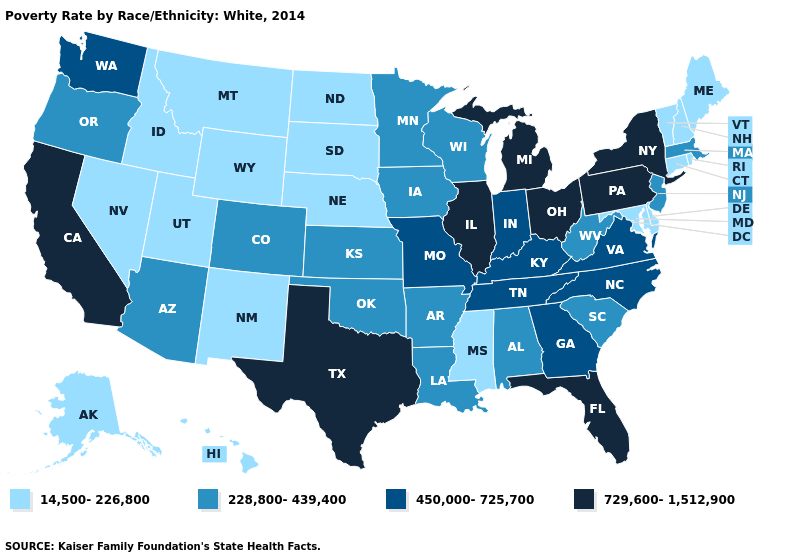What is the highest value in the Northeast ?
Short answer required. 729,600-1,512,900. What is the value of New York?
Concise answer only. 729,600-1,512,900. Among the states that border Nebraska , which have the highest value?
Keep it brief. Missouri. Does the first symbol in the legend represent the smallest category?
Quick response, please. Yes. What is the value of Delaware?
Write a very short answer. 14,500-226,800. What is the value of Virginia?
Keep it brief. 450,000-725,700. What is the value of Alabama?
Give a very brief answer. 228,800-439,400. Does New Mexico have the highest value in the West?
Answer briefly. No. Does Illinois have the same value as Maine?
Answer briefly. No. Name the states that have a value in the range 450,000-725,700?
Short answer required. Georgia, Indiana, Kentucky, Missouri, North Carolina, Tennessee, Virginia, Washington. Name the states that have a value in the range 729,600-1,512,900?
Keep it brief. California, Florida, Illinois, Michigan, New York, Ohio, Pennsylvania, Texas. Does Pennsylvania have the highest value in the USA?
Write a very short answer. Yes. Among the states that border Wyoming , which have the highest value?
Be succinct. Colorado. Is the legend a continuous bar?
Keep it brief. No. Which states have the lowest value in the South?
Write a very short answer. Delaware, Maryland, Mississippi. 